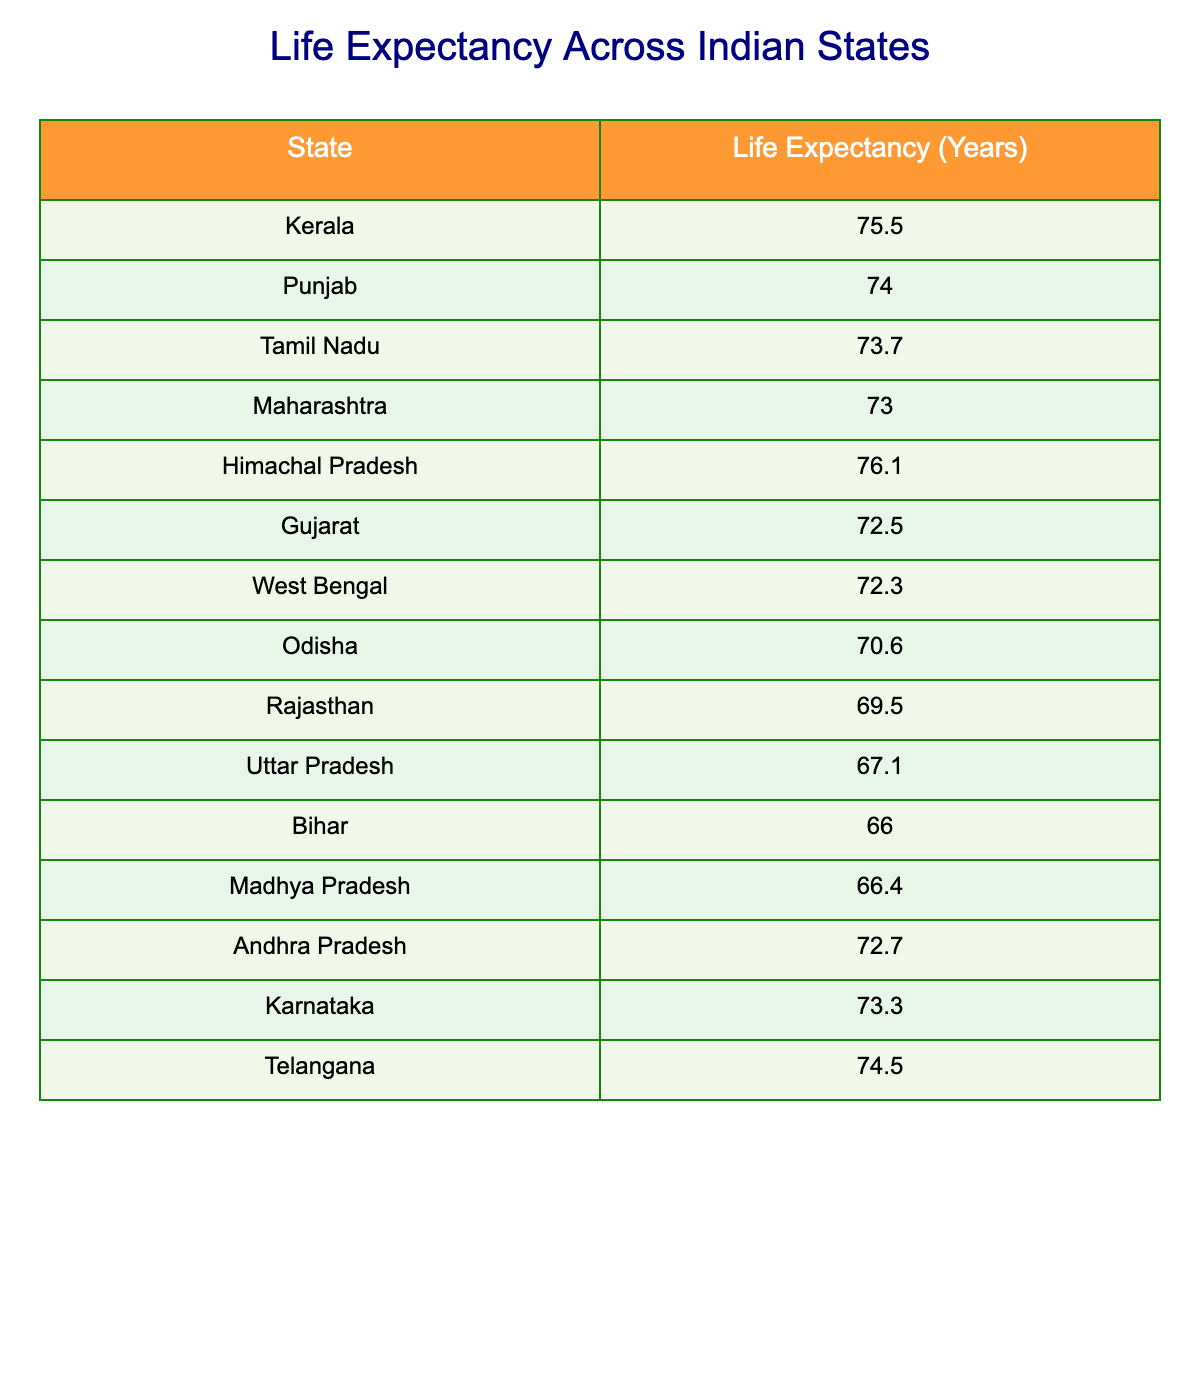What is the life expectancy of Kerala? The table lists Kerala’s life expectancy directly, showing it as 75.5 years.
Answer: 75.5 Which state has the lowest life expectancy? According to the table, Bihar has the lowest life expectancy at 66.0 years.
Answer: Bihar What is the average life expectancy of the states listed in the table? To find the average, sum all life expectancies: 75.5 + 74.0 + 73.7 + 73.0 + 76.1 + 72.5 + 72.3 + 70.6 + 69.5 + 67.1 + 66.0 + 66.4 + 72.7 + 73.3 + 74.5 = 1,095.5. There are 15 states, so the average is 1,095.5 / 15 = 73.03 (approximately).
Answer: 73.03 Is Tamil Nadu's life expectancy greater than that of Gujarat? Looking at the table, Tamil Nadu has a life expectancy of 73.7 years while Gujarat's is 72.5 years. Since 73.7 is greater than 72.5, the answer is yes.
Answer: Yes How much higher is the life expectancy of Himachal Pradesh than that of Uttar Pradesh? The life expectancy of Himachal Pradesh is 76.1 years, while that of Uttar Pradesh is 67.1 years. Subtracting these values gives: 76.1 - 67.1 = 9.0 years.
Answer: 9.0 Which states have a life expectancy greater than 74 years? Referring to the table, the states with life expectancy greater than 74 years are Kerala (75.5), Himachal Pradesh (76.1), and Telangana (74.5).
Answer: Kerala, Himachal Pradesh, Telangana If we rank the states by life expectancy, what position does Maharashtra hold? Referring to the table, Maharashtra has a life expectancy of 73.0 years. Counting upwards from the highest (Himachal Pradesh) down, it ranks as the seventh position in the list of 15 states when sorted from highest to lowest.
Answer: 7th Does Punjab have a higher life expectancy than Karnataka? Punjab’s life expectancy is 74.0 years, while Karnataka’s is 73.3 years. Comparing these two values shows that 74.0 is greater than 73.3, so the answer is yes.
Answer: Yes What is the difference between the life expectancies of the top-ranked and the bottom-ranked state? The top-ranked state is Himachal Pradesh with 76.1 years, and the bottom-ranked state is Bihar with 66.0 years. The difference is calculated as 76.1 - 66.0 = 10.1 years.
Answer: 10.1 